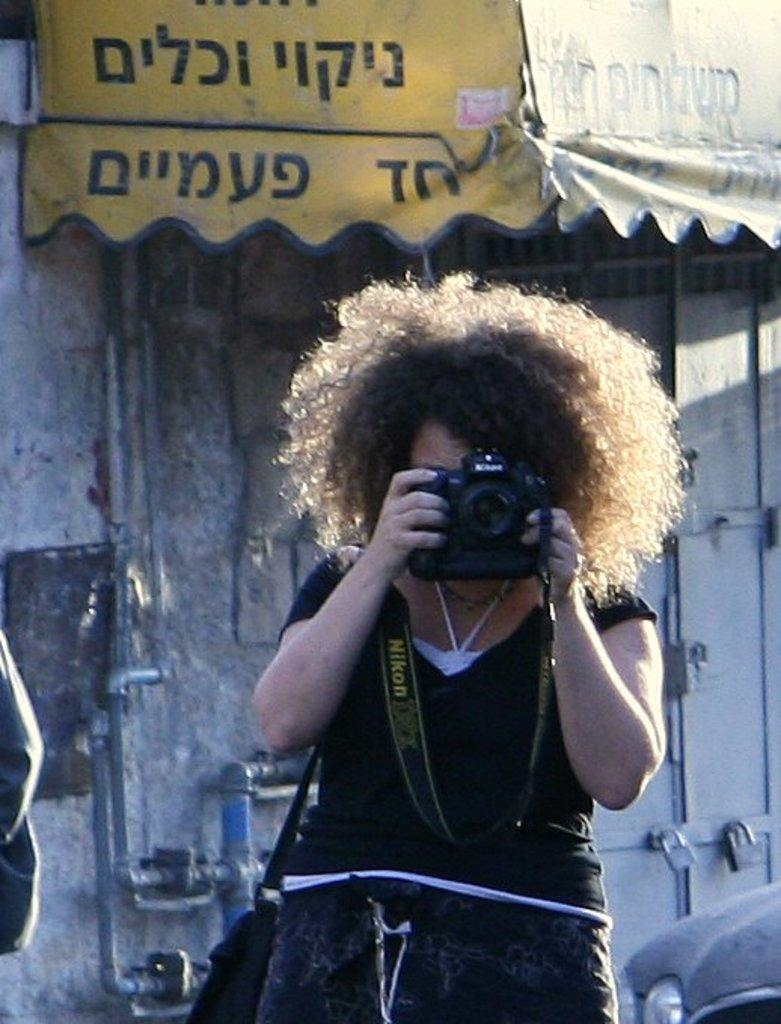What is the main subject of the image? There is a person in the image. What is the person holding in the image? The person is holding a camera with his hands. What can be seen in the background of the image? There is a wall in the background of the image. What type of key is the person using to adjust the light in the image? There is no key or light present in the image; the person is simply holding a camera. 